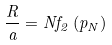<formula> <loc_0><loc_0><loc_500><loc_500>\frac { R } { a } = N f _ { 2 } \left ( p _ { N } \right )</formula> 